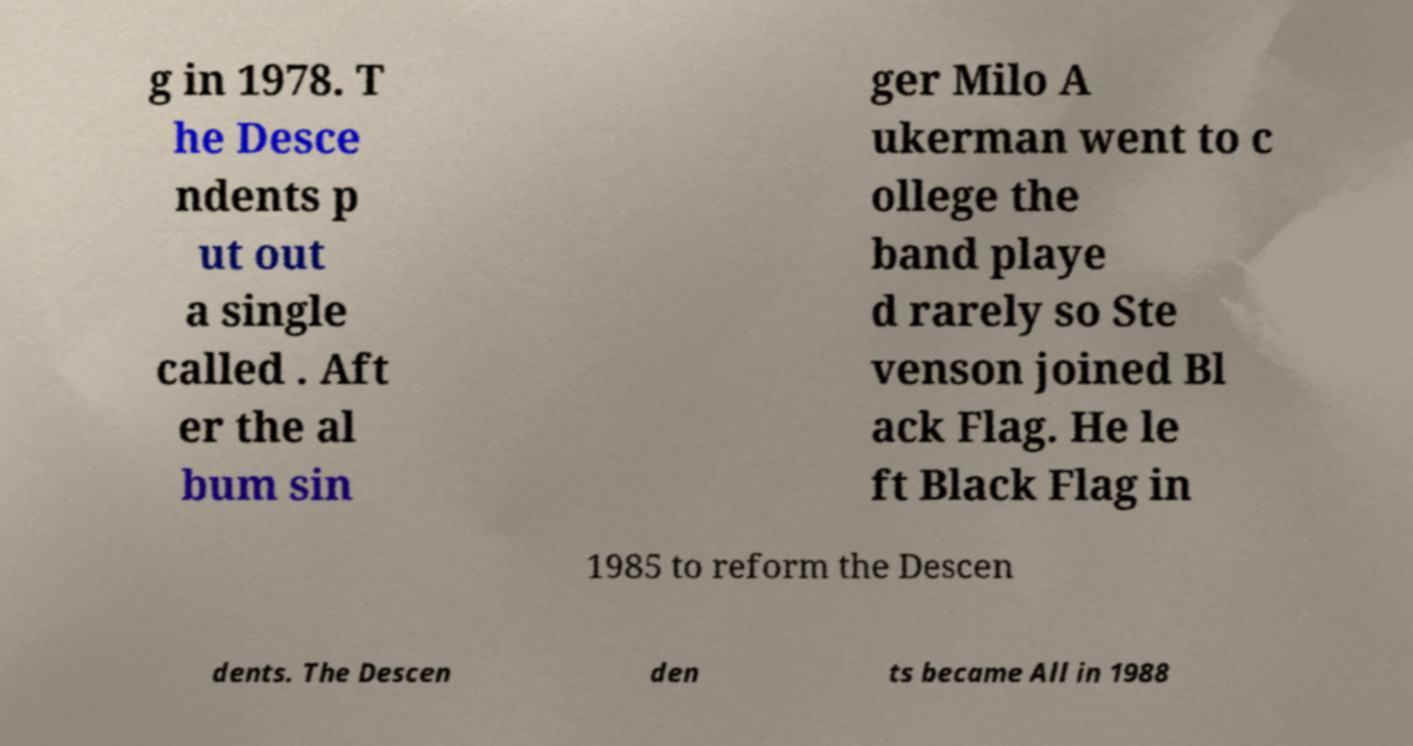Please identify and transcribe the text found in this image. g in 1978. T he Desce ndents p ut out a single called . Aft er the al bum sin ger Milo A ukerman went to c ollege the band playe d rarely so Ste venson joined Bl ack Flag. He le ft Black Flag in 1985 to reform the Descen dents. The Descen den ts became All in 1988 